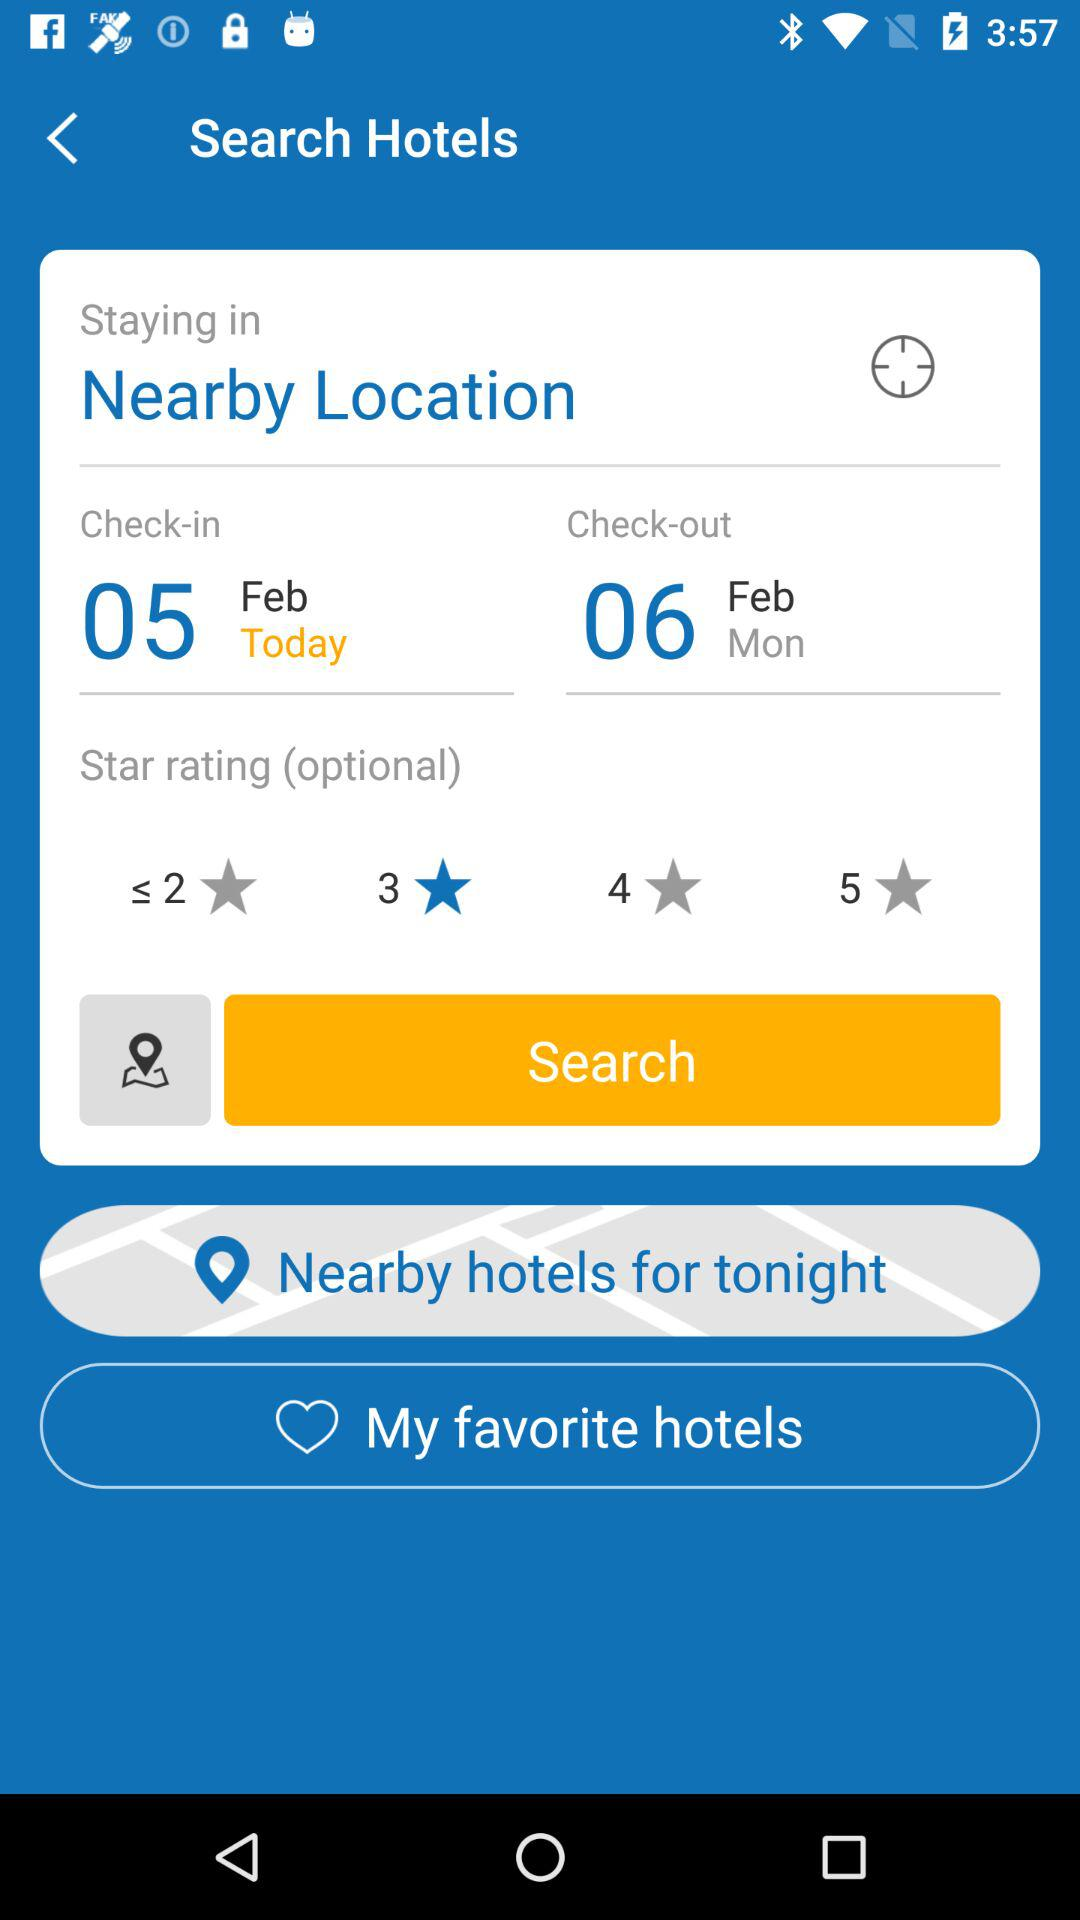What is the check-out date? The check-out date is Monday, February 6. 